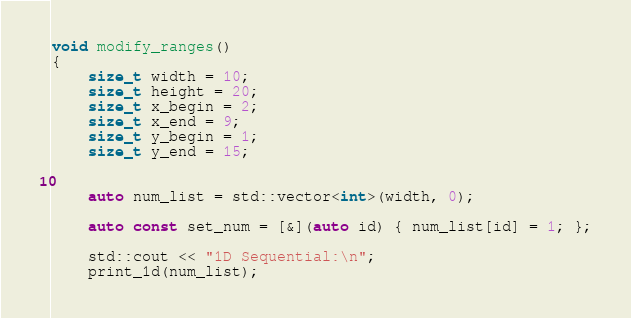Convert code to text. <code><loc_0><loc_0><loc_500><loc_500><_C++_>

void modify_ranges()
{
	size_t width = 10;
	size_t height = 20;
	size_t x_begin = 2;
	size_t x_end = 9;
	size_t y_begin = 1;
	size_t y_end = 15;
	
	
	auto num_list = std::vector<int>(width, 0);

	auto const set_num = [&](auto id) { num_list[id] = 1; };

	std::cout << "1D Sequential:\n";
	print_1d(num_list);	</code> 